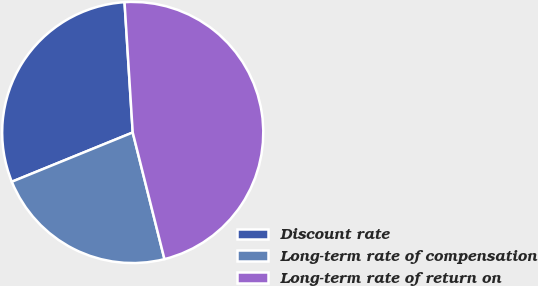Convert chart to OTSL. <chart><loc_0><loc_0><loc_500><loc_500><pie_chart><fcel>Discount rate<fcel>Long-term rate of compensation<fcel>Long-term rate of return on<nl><fcel>30.16%<fcel>22.75%<fcel>47.09%<nl></chart> 